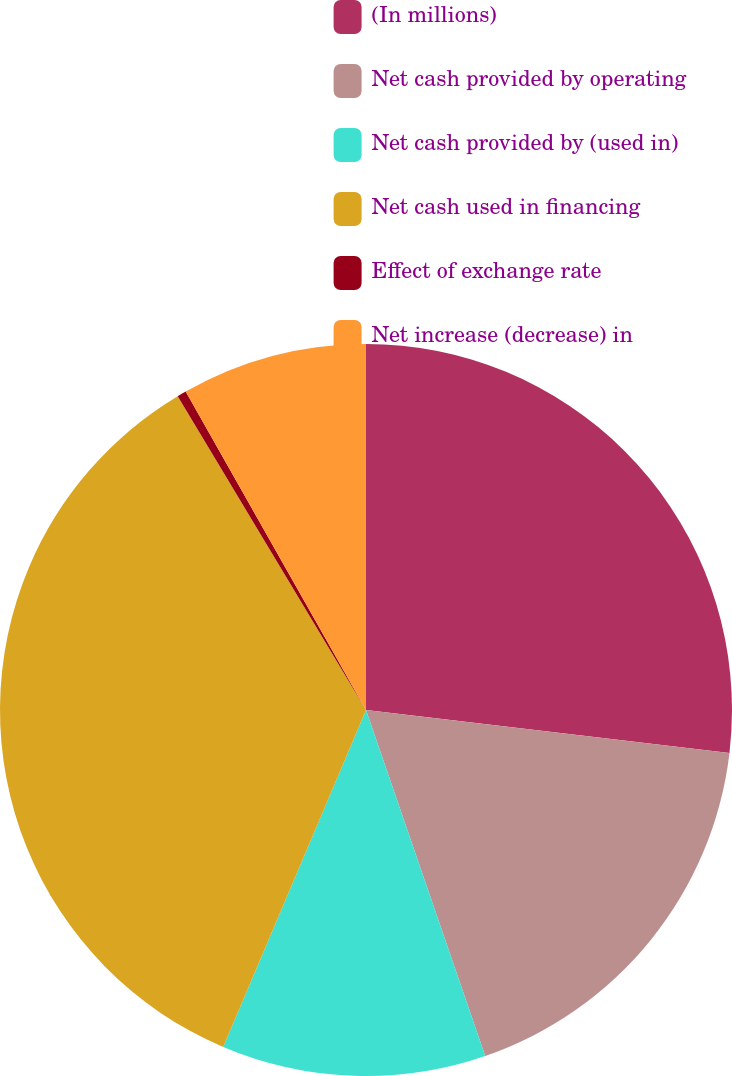<chart> <loc_0><loc_0><loc_500><loc_500><pie_chart><fcel>(In millions)<fcel>Net cash provided by operating<fcel>Net cash provided by (used in)<fcel>Net cash used in financing<fcel>Effect of exchange rate<fcel>Net increase (decrease) in<nl><fcel>26.87%<fcel>17.85%<fcel>11.66%<fcel>35.02%<fcel>0.4%<fcel>8.2%<nl></chart> 